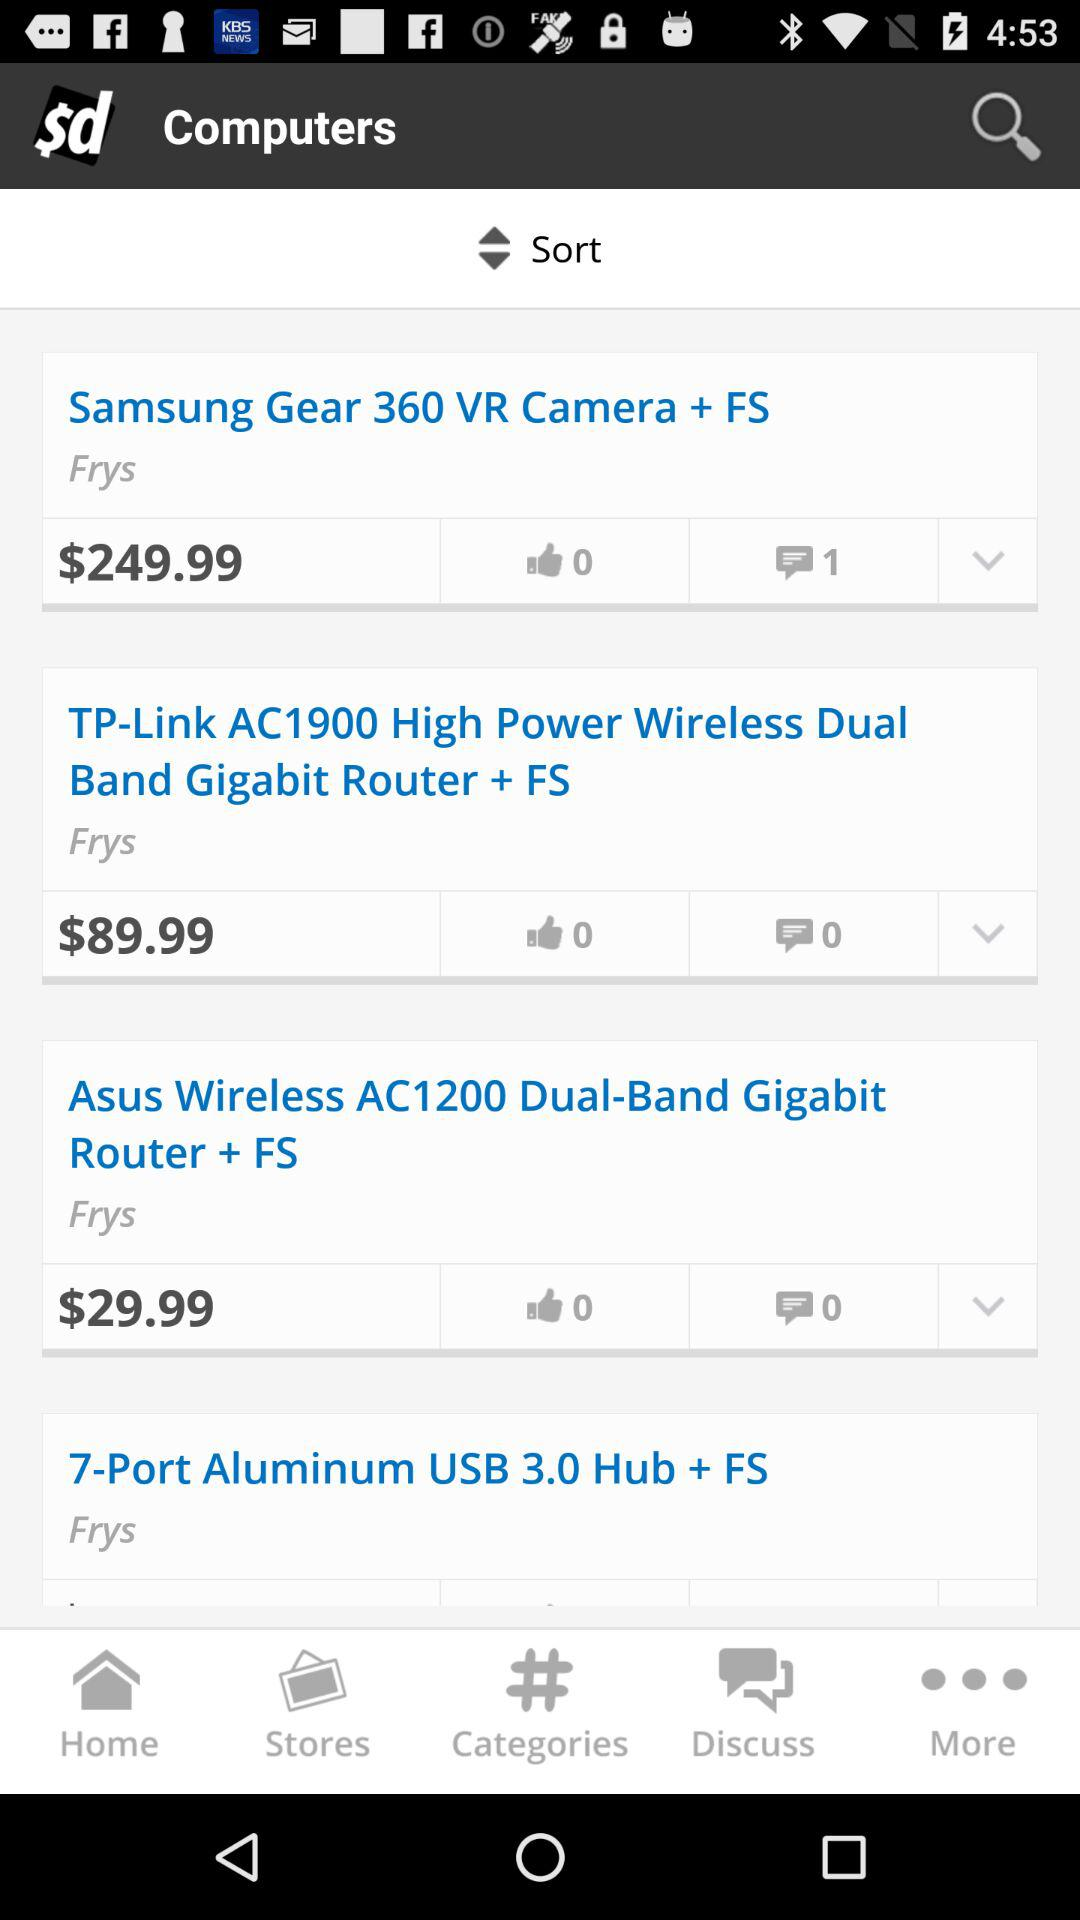What is the price of "TP-Link AC1900"? Its price is $89.99. 